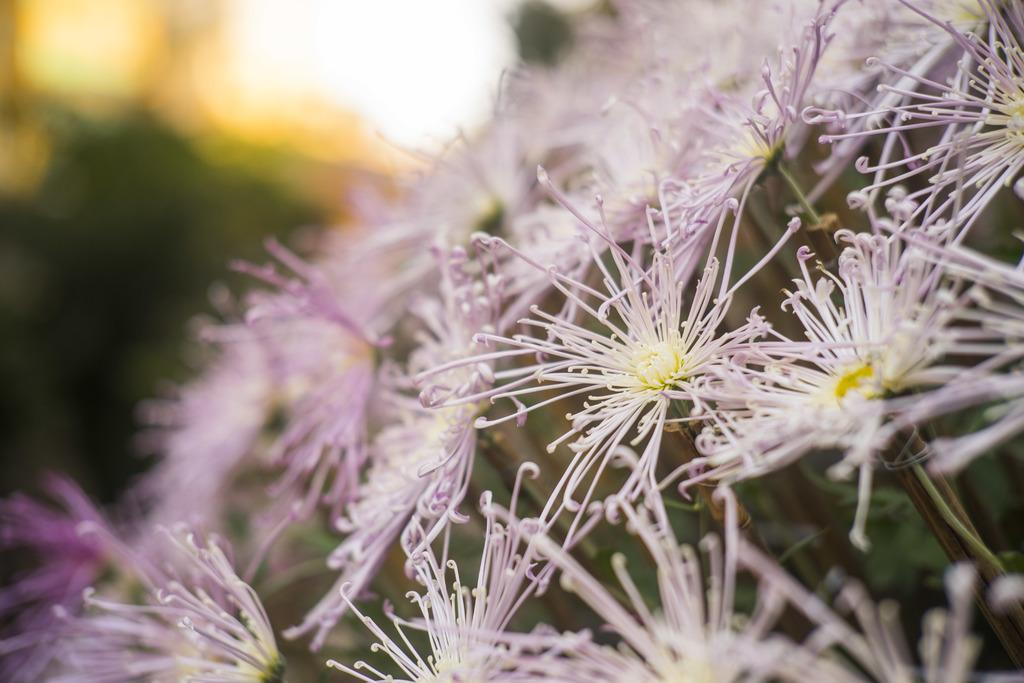What type of plants can be seen in the image? There are flowers in the image. Can you describe the background of the image? The background of the image is blurry. How many tests are being conducted in the image? There is no indication of any tests being conducted in the image. 